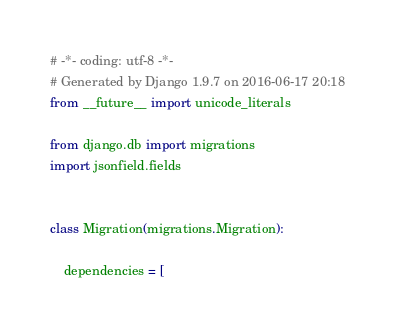Convert code to text. <code><loc_0><loc_0><loc_500><loc_500><_Python_># -*- coding: utf-8 -*-
# Generated by Django 1.9.7 on 2016-06-17 20:18
from __future__ import unicode_literals

from django.db import migrations
import jsonfield.fields


class Migration(migrations.Migration):

    dependencies = [</code> 